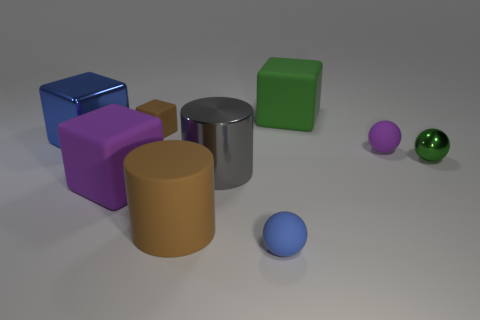What is the material of the green object on the right side of the matte cube that is right of the brown matte object that is in front of the blue cube?
Make the answer very short. Metal. How many objects are either small things in front of the tiny metallic thing or large things in front of the big blue object?
Provide a succinct answer. 4. There is a tiny blue thing that is the same shape as the small green thing; what material is it?
Your answer should be very brief. Rubber. What number of metallic objects are small cubes or gray cylinders?
Offer a terse response. 1. There is a small blue thing that is made of the same material as the tiny purple sphere; what is its shape?
Keep it short and to the point. Sphere. How many large brown matte objects are the same shape as the gray thing?
Give a very brief answer. 1. There is a matte object that is right of the large green matte block; does it have the same shape as the blue thing that is behind the tiny blue rubber ball?
Your answer should be very brief. No. What number of things are either large green cylinders or objects that are to the right of the large metal cylinder?
Offer a terse response. 4. There is a small object that is the same color as the shiny block; what is its shape?
Ensure brevity in your answer.  Sphere. How many blue blocks are the same size as the purple rubber cube?
Your response must be concise. 1. 